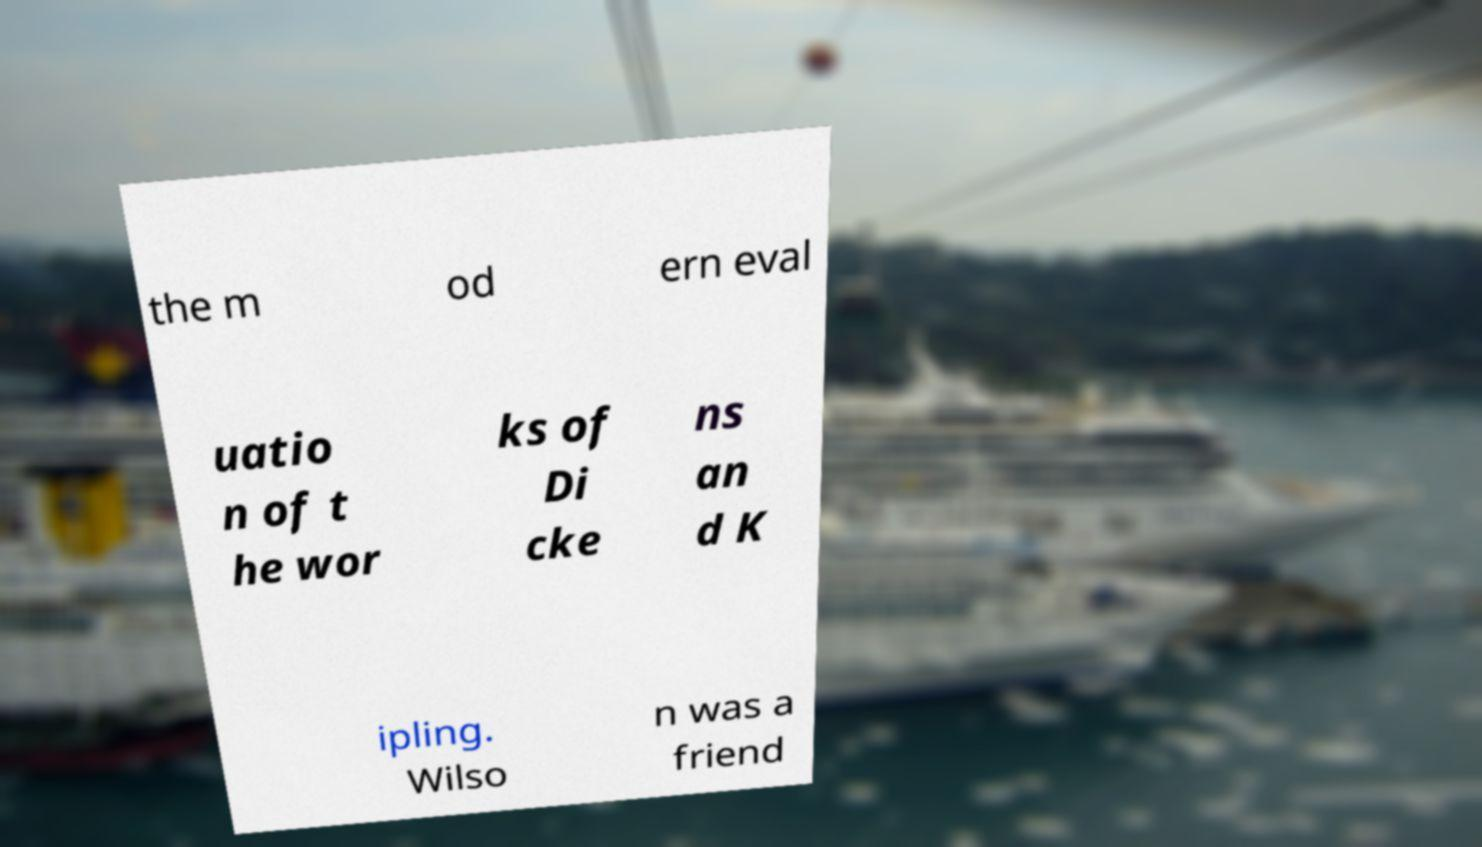I need the written content from this picture converted into text. Can you do that? the m od ern eval uatio n of t he wor ks of Di cke ns an d K ipling. Wilso n was a friend 